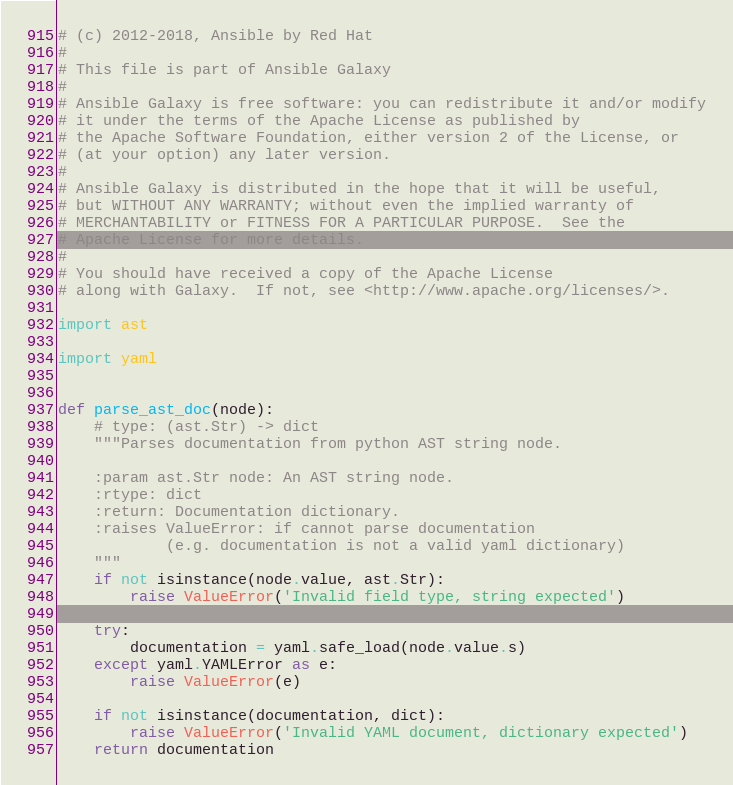<code> <loc_0><loc_0><loc_500><loc_500><_Python_># (c) 2012-2018, Ansible by Red Hat
#
# This file is part of Ansible Galaxy
#
# Ansible Galaxy is free software: you can redistribute it and/or modify
# it under the terms of the Apache License as published by
# the Apache Software Foundation, either version 2 of the License, or
# (at your option) any later version.
#
# Ansible Galaxy is distributed in the hope that it will be useful,
# but WITHOUT ANY WARRANTY; without even the implied warranty of
# MERCHANTABILITY or FITNESS FOR A PARTICULAR PURPOSE.  See the
# Apache License for more details.
#
# You should have received a copy of the Apache License
# along with Galaxy.  If not, see <http://www.apache.org/licenses/>.

import ast

import yaml


def parse_ast_doc(node):
    # type: (ast.Str) -> dict
    """Parses documentation from python AST string node.

    :param ast.Str node: An AST string node.
    :rtype: dict
    :return: Documentation dictionary.
    :raises ValueError: if cannot parse documentation
            (e.g. documentation is not a valid yaml dictionary)
    """
    if not isinstance(node.value, ast.Str):
        raise ValueError('Invalid field type, string expected')

    try:
        documentation = yaml.safe_load(node.value.s)
    except yaml.YAMLError as e:
        raise ValueError(e)

    if not isinstance(documentation, dict):
        raise ValueError('Invalid YAML document, dictionary expected')
    return documentation
</code> 